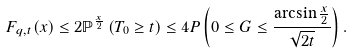<formula> <loc_0><loc_0><loc_500><loc_500>F _ { q , t } ( x ) \leq 2 \mathbb { P } ^ { \frac { x } { 2 } } \left ( T _ { 0 } \geq t \right ) \leq 4 P \left ( 0 \leq G \leq \frac { \arcsin \frac { x } { 2 } } { \sqrt { 2 t } } \right ) .</formula> 